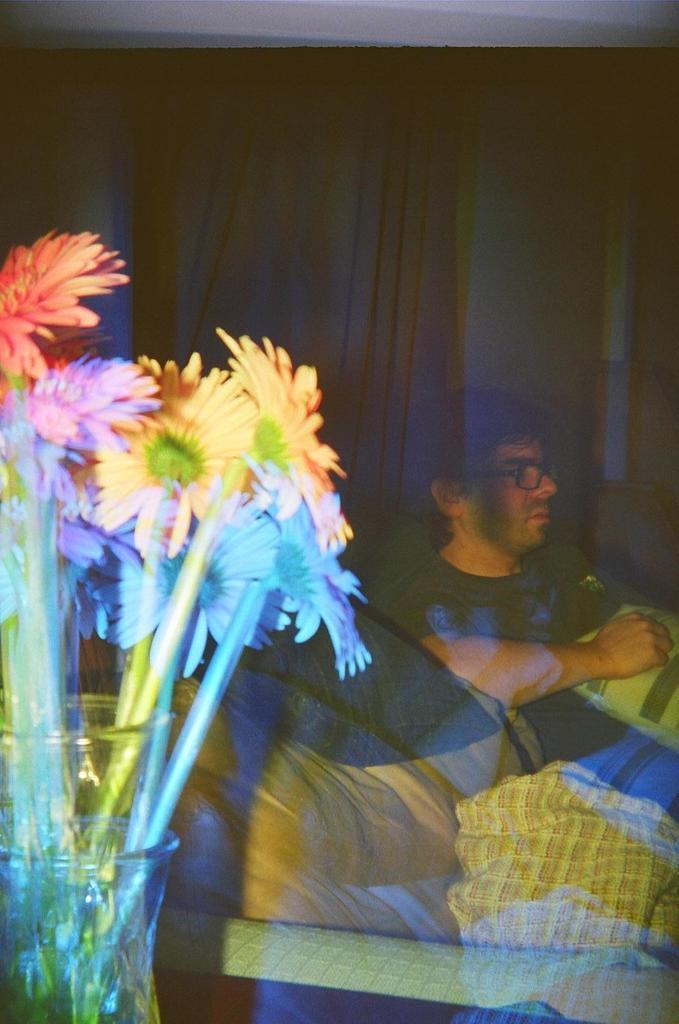In one or two sentences, can you explain what this image depicts? In this picture we can see a few flowers, stems and glass objects. We can see a person, a pillow and other objects. 